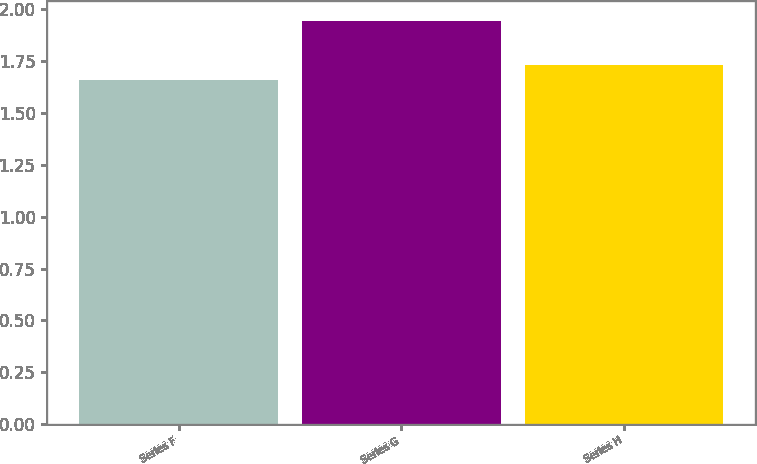<chart> <loc_0><loc_0><loc_500><loc_500><bar_chart><fcel>Series F<fcel>Series G<fcel>Series H<nl><fcel>1.66<fcel>1.94<fcel>1.73<nl></chart> 